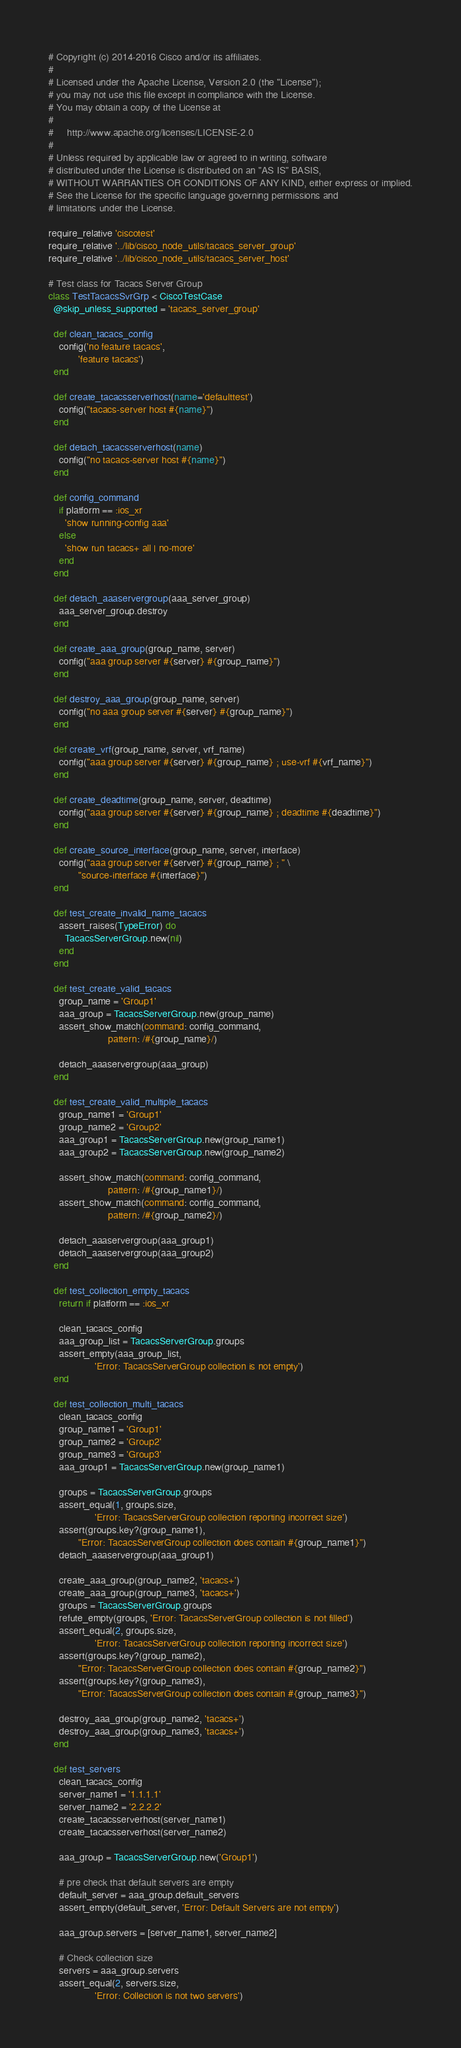<code> <loc_0><loc_0><loc_500><loc_500><_Ruby_># Copyright (c) 2014-2016 Cisco and/or its affiliates.
#
# Licensed under the Apache License, Version 2.0 (the "License");
# you may not use this file except in compliance with the License.
# You may obtain a copy of the License at
#
#     http://www.apache.org/licenses/LICENSE-2.0
#
# Unless required by applicable law or agreed to in writing, software
# distributed under the License is distributed on an "AS IS" BASIS,
# WITHOUT WARRANTIES OR CONDITIONS OF ANY KIND, either express or implied.
# See the License for the specific language governing permissions and
# limitations under the License.

require_relative 'ciscotest'
require_relative '../lib/cisco_node_utils/tacacs_server_group'
require_relative '../lib/cisco_node_utils/tacacs_server_host'

# Test class for Tacacs Server Group
class TestTacacsSvrGrp < CiscoTestCase
  @skip_unless_supported = 'tacacs_server_group'

  def clean_tacacs_config
    config('no feature tacacs',
           'feature tacacs')
  end

  def create_tacacsserverhost(name='defaulttest')
    config("tacacs-server host #{name}")
  end

  def detach_tacacsserverhost(name)
    config("no tacacs-server host #{name}")
  end

  def config_command
    if platform == :ios_xr
      'show running-config aaa'
    else
      'show run tacacs+ all | no-more'
    end
  end

  def detach_aaaservergroup(aaa_server_group)
    aaa_server_group.destroy
  end

  def create_aaa_group(group_name, server)
    config("aaa group server #{server} #{group_name}")
  end

  def destroy_aaa_group(group_name, server)
    config("no aaa group server #{server} #{group_name}")
  end

  def create_vrf(group_name, server, vrf_name)
    config("aaa group server #{server} #{group_name} ; use-vrf #{vrf_name}")
  end

  def create_deadtime(group_name, server, deadtime)
    config("aaa group server #{server} #{group_name} ; deadtime #{deadtime}")
  end

  def create_source_interface(group_name, server, interface)
    config("aaa group server #{server} #{group_name} ; " \
           "source-interface #{interface}")
  end

  def test_create_invalid_name_tacacs
    assert_raises(TypeError) do
      TacacsServerGroup.new(nil)
    end
  end

  def test_create_valid_tacacs
    group_name = 'Group1'
    aaa_group = TacacsServerGroup.new(group_name)
    assert_show_match(command: config_command,
                      pattern: /#{group_name}/)

    detach_aaaservergroup(aaa_group)
  end

  def test_create_valid_multiple_tacacs
    group_name1 = 'Group1'
    group_name2 = 'Group2'
    aaa_group1 = TacacsServerGroup.new(group_name1)
    aaa_group2 = TacacsServerGroup.new(group_name2)

    assert_show_match(command: config_command,
                      pattern: /#{group_name1}/)
    assert_show_match(command: config_command,
                      pattern: /#{group_name2}/)

    detach_aaaservergroup(aaa_group1)
    detach_aaaservergroup(aaa_group2)
  end

  def test_collection_empty_tacacs
    return if platform == :ios_xr

    clean_tacacs_config
    aaa_group_list = TacacsServerGroup.groups
    assert_empty(aaa_group_list,
                 'Error: TacacsServerGroup collection is not empty')
  end

  def test_collection_multi_tacacs
    clean_tacacs_config
    group_name1 = 'Group1'
    group_name2 = 'Group2'
    group_name3 = 'Group3'
    aaa_group1 = TacacsServerGroup.new(group_name1)

    groups = TacacsServerGroup.groups
    assert_equal(1, groups.size,
                 'Error: TacacsServerGroup collection reporting incorrect size')
    assert(groups.key?(group_name1),
           "Error: TacacsServerGroup collection does contain #{group_name1}")
    detach_aaaservergroup(aaa_group1)

    create_aaa_group(group_name2, 'tacacs+')
    create_aaa_group(group_name3, 'tacacs+')
    groups = TacacsServerGroup.groups
    refute_empty(groups, 'Error: TacacsServerGroup collection is not filled')
    assert_equal(2, groups.size,
                 'Error: TacacsServerGroup collection reporting incorrect size')
    assert(groups.key?(group_name2),
           "Error: TacacsServerGroup collection does contain #{group_name2}")
    assert(groups.key?(group_name3),
           "Error: TacacsServerGroup collection does contain #{group_name3}")

    destroy_aaa_group(group_name2, 'tacacs+')
    destroy_aaa_group(group_name3, 'tacacs+')
  end

  def test_servers
    clean_tacacs_config
    server_name1 = '1.1.1.1'
    server_name2 = '2.2.2.2'
    create_tacacsserverhost(server_name1)
    create_tacacsserverhost(server_name2)

    aaa_group = TacacsServerGroup.new('Group1')

    # pre check that default servers are empty
    default_server = aaa_group.default_servers
    assert_empty(default_server, 'Error: Default Servers are not empty')

    aaa_group.servers = [server_name1, server_name2]

    # Check collection size
    servers = aaa_group.servers
    assert_equal(2, servers.size,
                 'Error: Collection is not two servers')</code> 